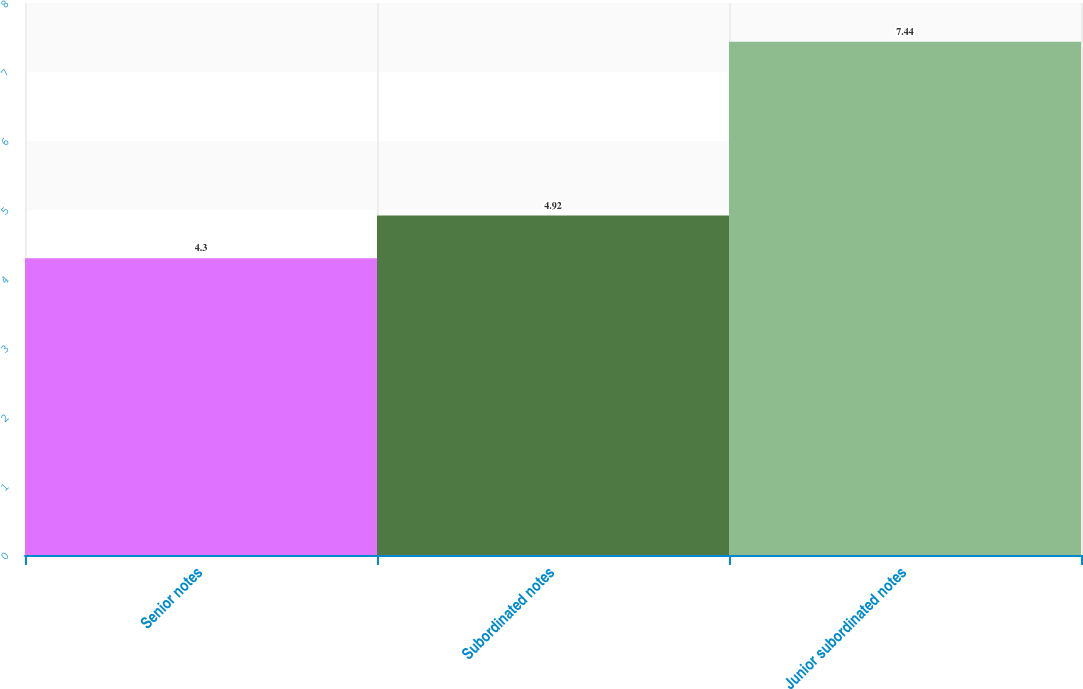<chart> <loc_0><loc_0><loc_500><loc_500><bar_chart><fcel>Senior notes<fcel>Subordinated notes<fcel>Junior subordinated notes<nl><fcel>4.3<fcel>4.92<fcel>7.44<nl></chart> 